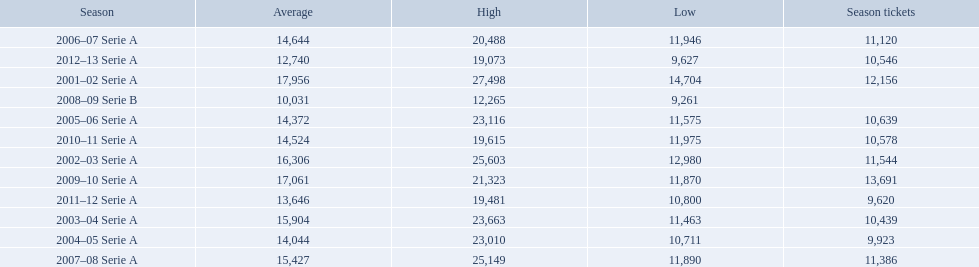What are the seasons? 2001–02 Serie A, 2002–03 Serie A, 2003–04 Serie A, 2004–05 Serie A, 2005–06 Serie A, 2006–07 Serie A, 2007–08 Serie A, 2008–09 Serie B, 2009–10 Serie A, 2010–11 Serie A, 2011–12 Serie A, 2012–13 Serie A. Which season is in 2007? 2007–08 Serie A. How many season tickets were sold that season? 11,386. 